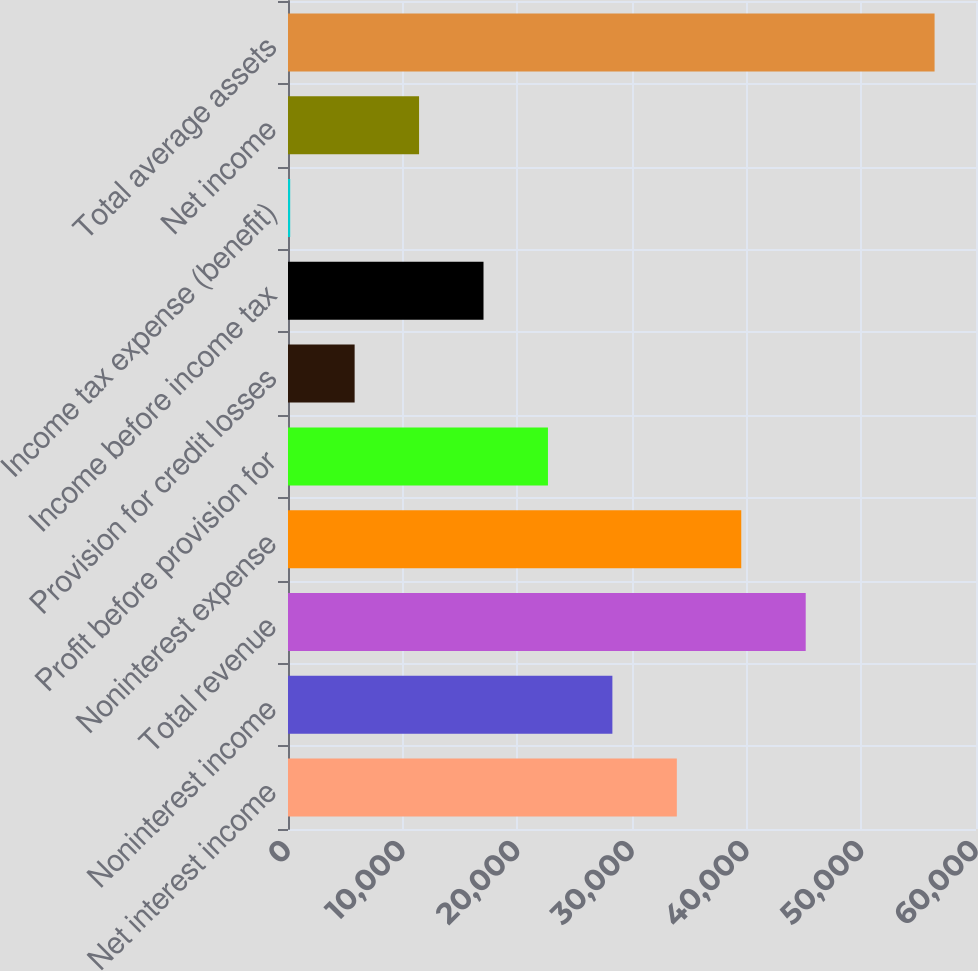<chart> <loc_0><loc_0><loc_500><loc_500><bar_chart><fcel>Net interest income<fcel>Noninterest income<fcel>Total revenue<fcel>Noninterest expense<fcel>Profit before provision for<fcel>Provision for credit losses<fcel>Income before income tax<fcel>Income tax expense (benefit)<fcel>Net income<fcel>Total average assets<nl><fcel>33909.2<fcel>28289.5<fcel>45148.6<fcel>39528.9<fcel>22669.8<fcel>5810.7<fcel>17050.1<fcel>191<fcel>11430.4<fcel>56388<nl></chart> 